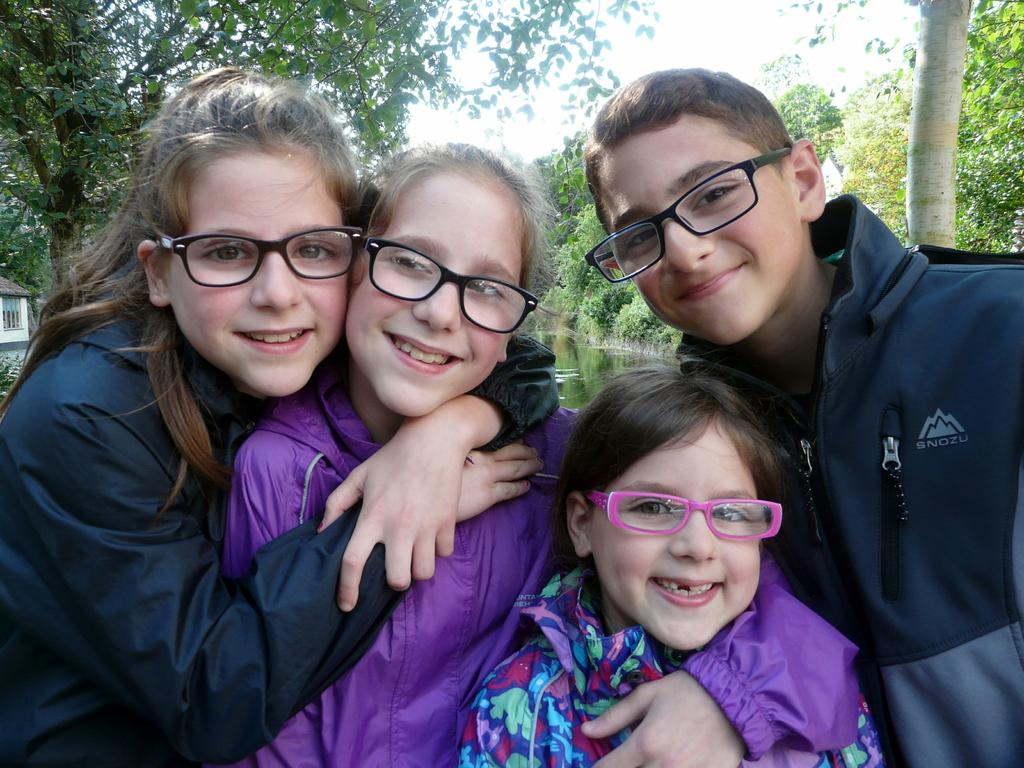How many people are present in the image? There are four people in the image. What are the people wearing? Each person is wearing spectacles. What is the facial expression of the people in the image? The people are smiling. What can be seen in the background of the image? There are trees in the background of the image. What type of art is being distributed by the people in the image? There is no art or distribution activity depicted in the image; it simply shows four people wearing spectacles and smiling. 